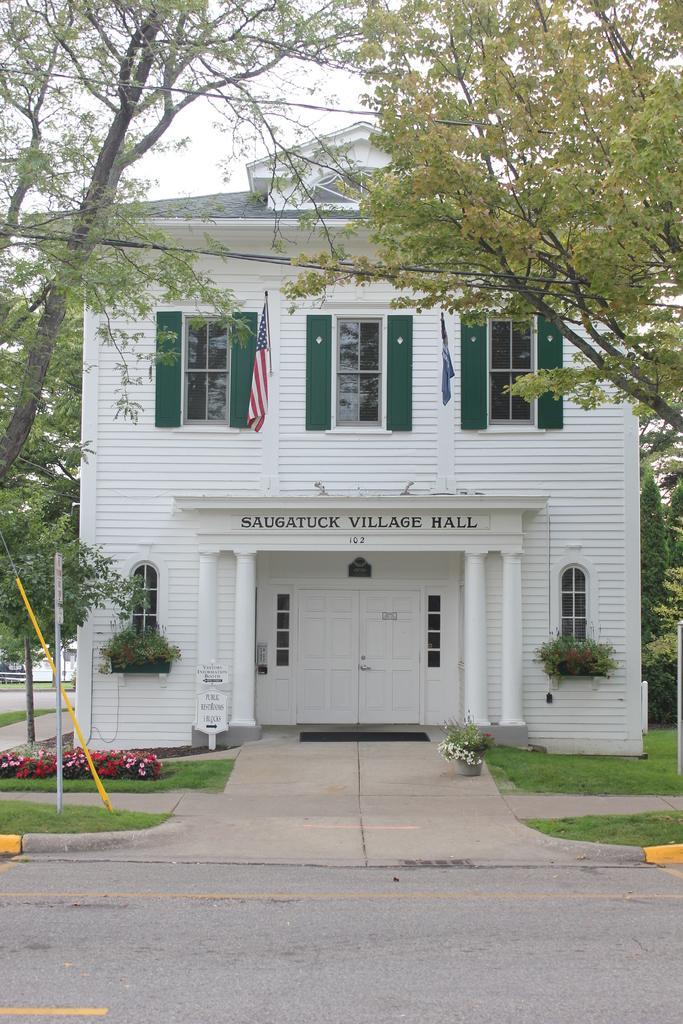In one or two sentences, can you explain what this image depicts? In this picture I can see a building,few trees and couple of flags and I can see text on the wall. I can see plants, flowers and grass on the ground and looks like a building in the back and I can see a cloudy sky. 